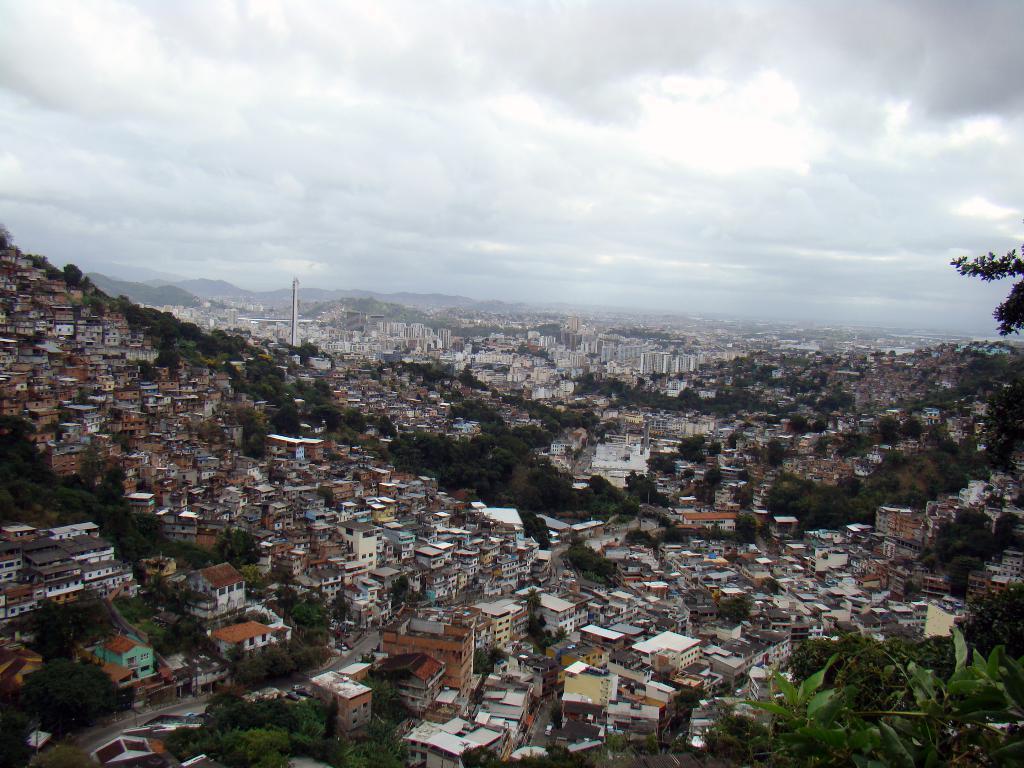How would you summarize this image in a sentence or two? This picture is clicked outside the city. In this picture, there are trees and buildings. In the background, we see the hills, trees and buildings. At the top, we see the sky and the clouds. 